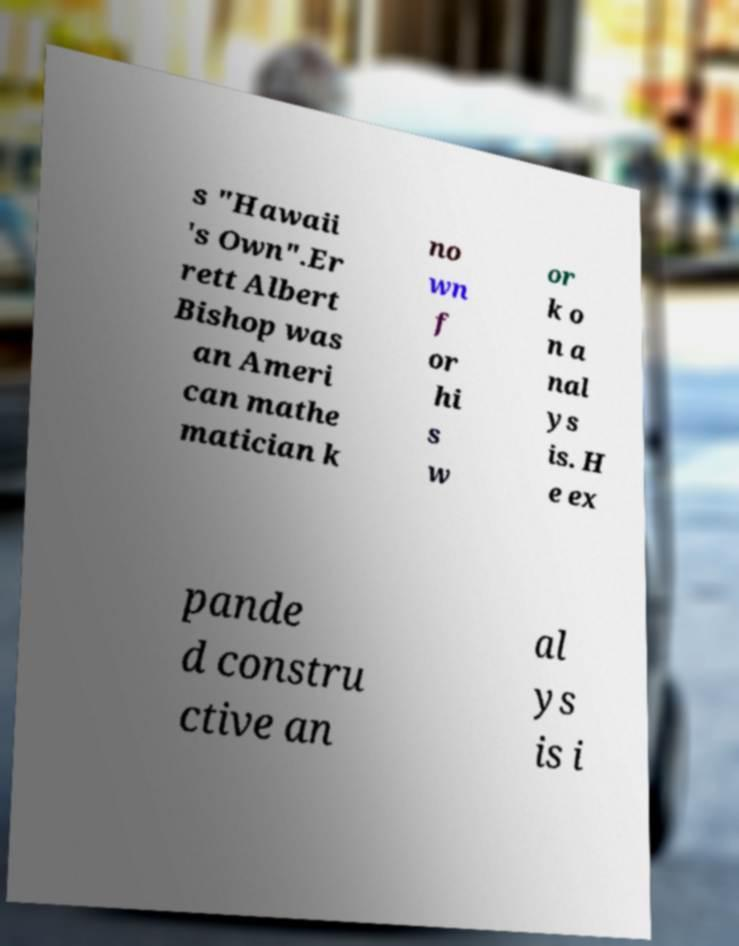Please read and relay the text visible in this image. What does it say? s "Hawaii 's Own".Er rett Albert Bishop was an Ameri can mathe matician k no wn f or hi s w or k o n a nal ys is. H e ex pande d constru ctive an al ys is i 